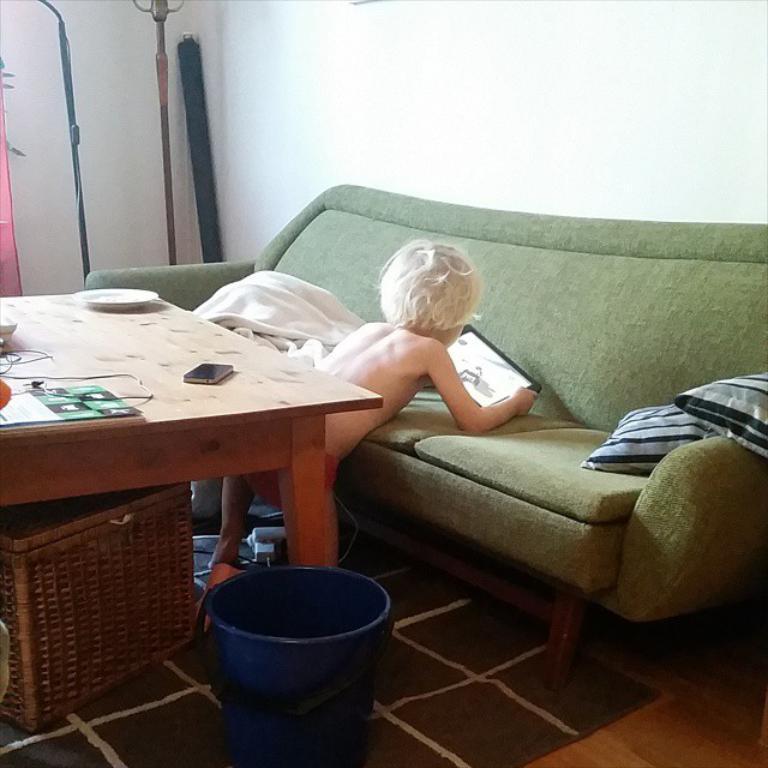Describe this image in one or two sentences. In this image I can see a person a with a phone. I can also see a sofa and few cushions on it. Here on this table I can see one more phone and few plates. 